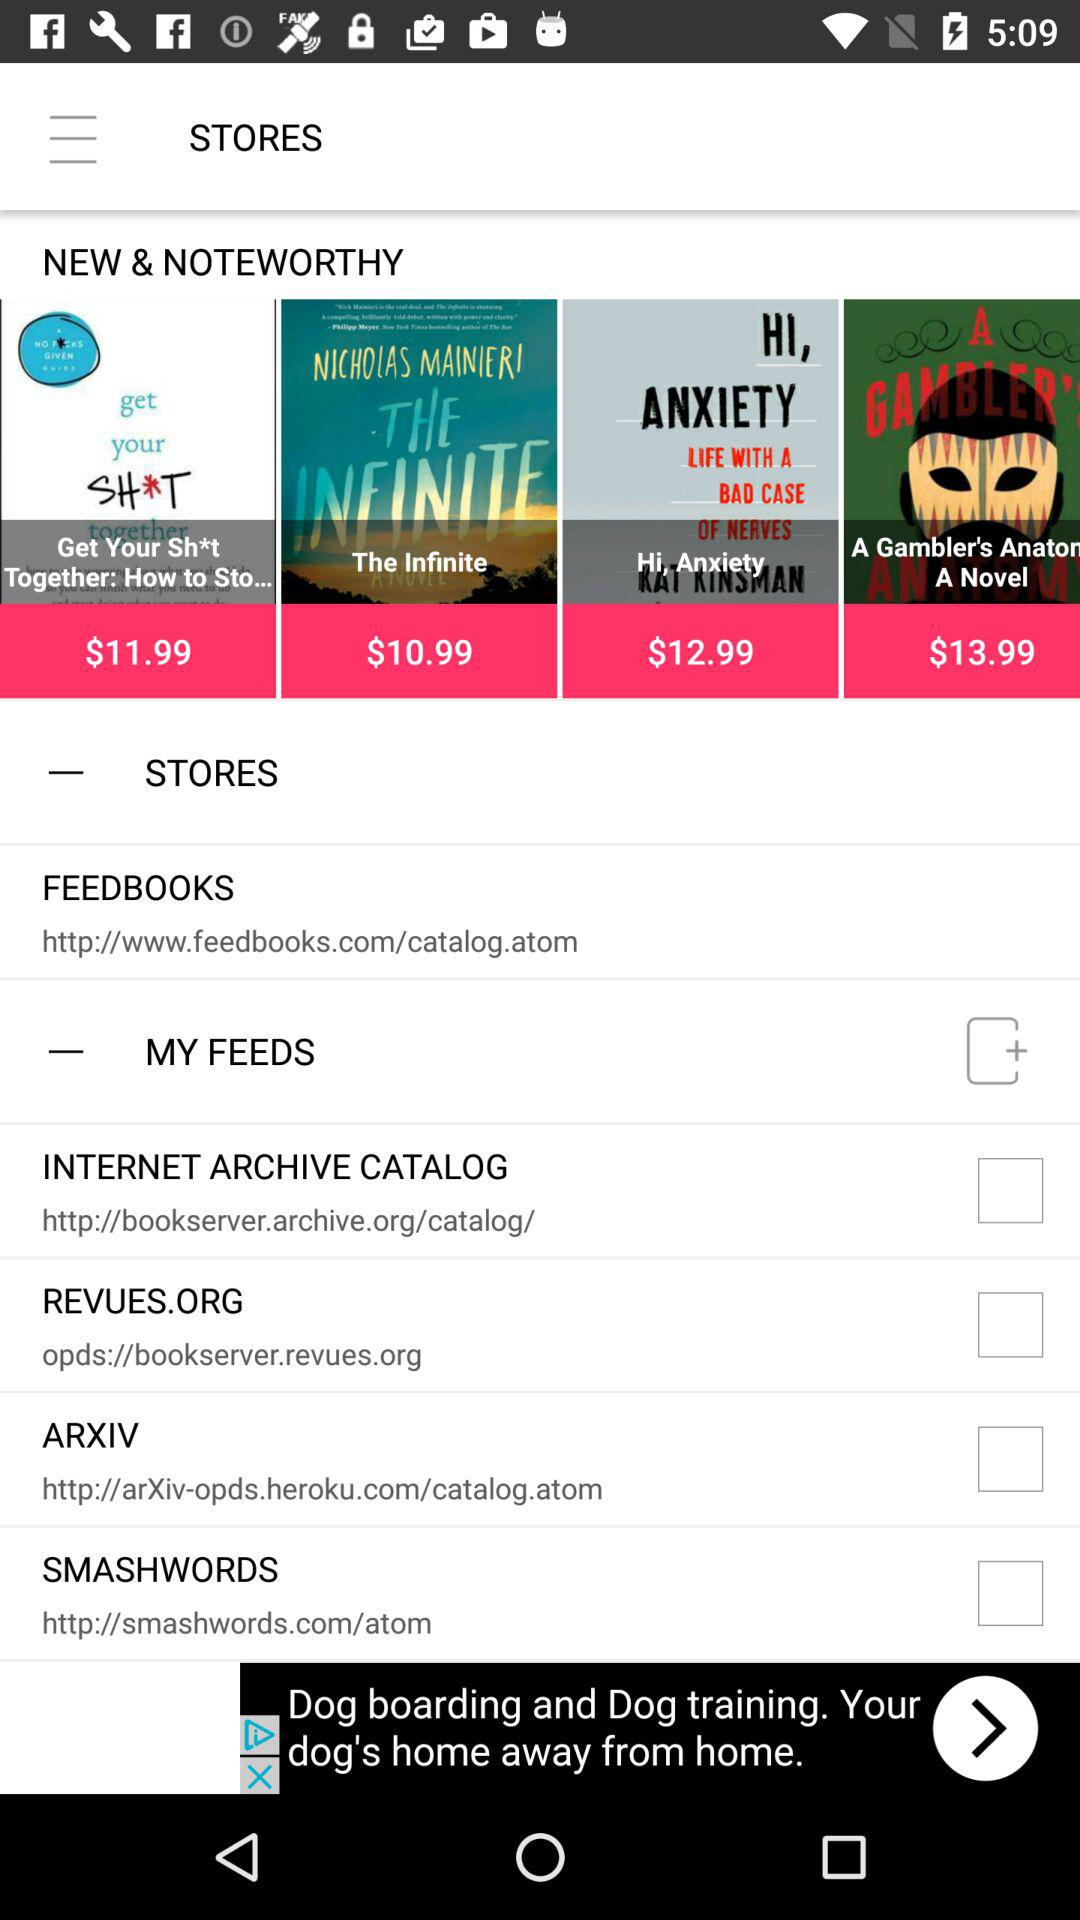What's the URL for ARXIV? The URL for ARXIV is http://arXiv-opds.heroku.com/catalog.atom. 